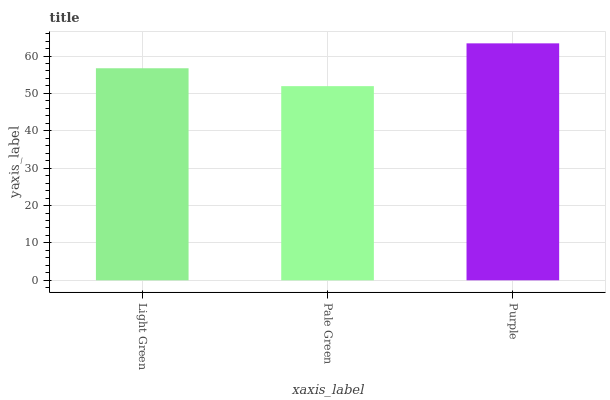Is Pale Green the minimum?
Answer yes or no. Yes. Is Purple the maximum?
Answer yes or no. Yes. Is Purple the minimum?
Answer yes or no. No. Is Pale Green the maximum?
Answer yes or no. No. Is Purple greater than Pale Green?
Answer yes or no. Yes. Is Pale Green less than Purple?
Answer yes or no. Yes. Is Pale Green greater than Purple?
Answer yes or no. No. Is Purple less than Pale Green?
Answer yes or no. No. Is Light Green the high median?
Answer yes or no. Yes. Is Light Green the low median?
Answer yes or no. Yes. Is Pale Green the high median?
Answer yes or no. No. Is Purple the low median?
Answer yes or no. No. 